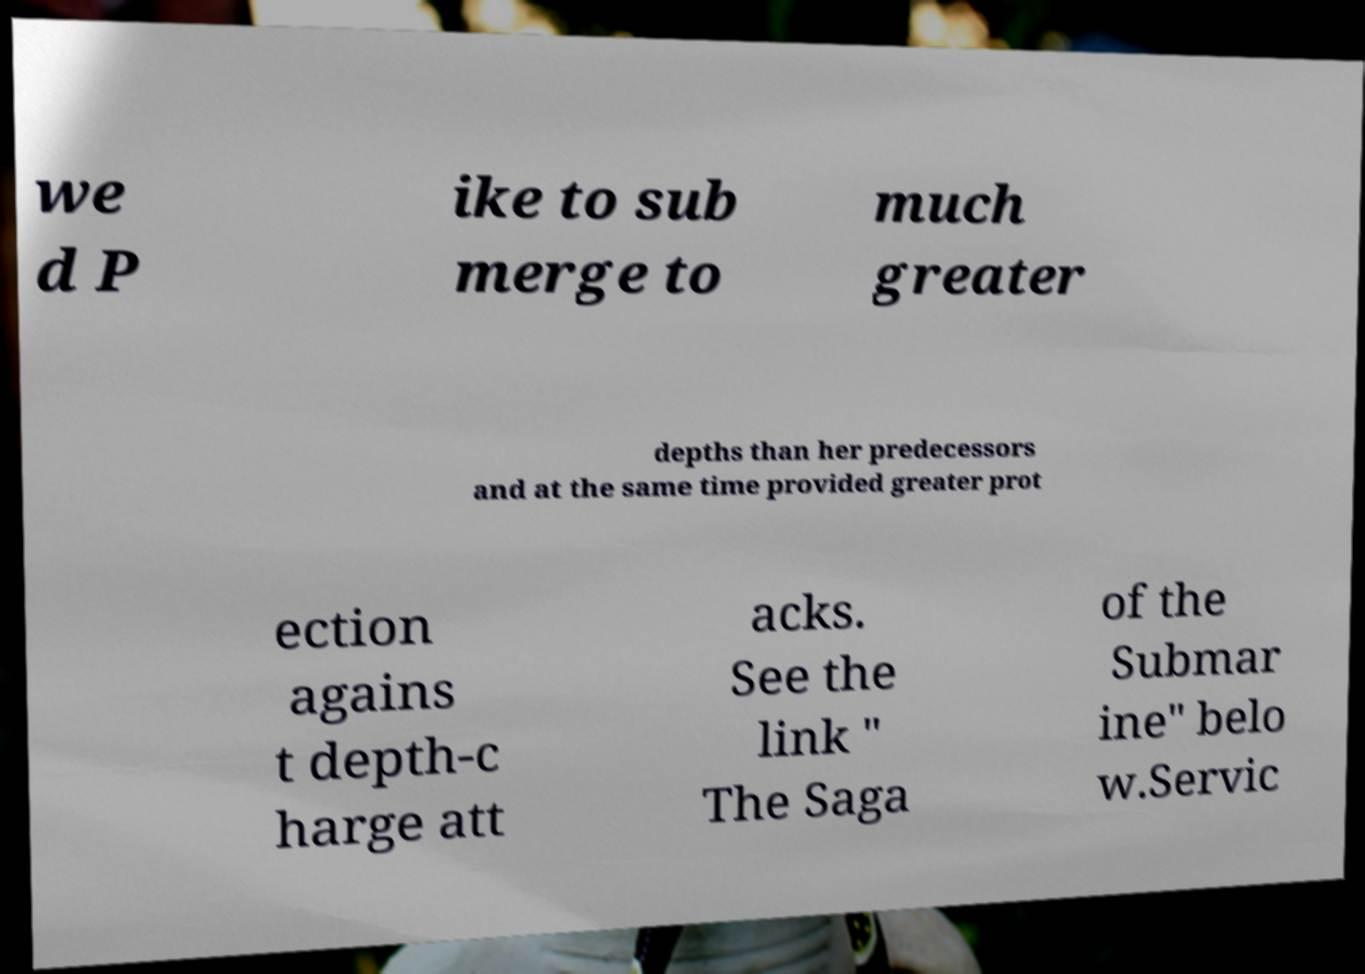For documentation purposes, I need the text within this image transcribed. Could you provide that? we d P ike to sub merge to much greater depths than her predecessors and at the same time provided greater prot ection agains t depth-c harge att acks. See the link " The Saga of the Submar ine" belo w.Servic 